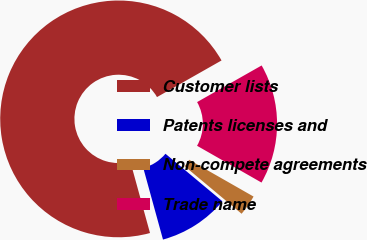<chart> <loc_0><loc_0><loc_500><loc_500><pie_chart><fcel>Customer lists<fcel>Patents licenses and<fcel>Non-compete agreements<fcel>Trade name<nl><fcel>71.06%<fcel>9.65%<fcel>2.82%<fcel>16.47%<nl></chart> 